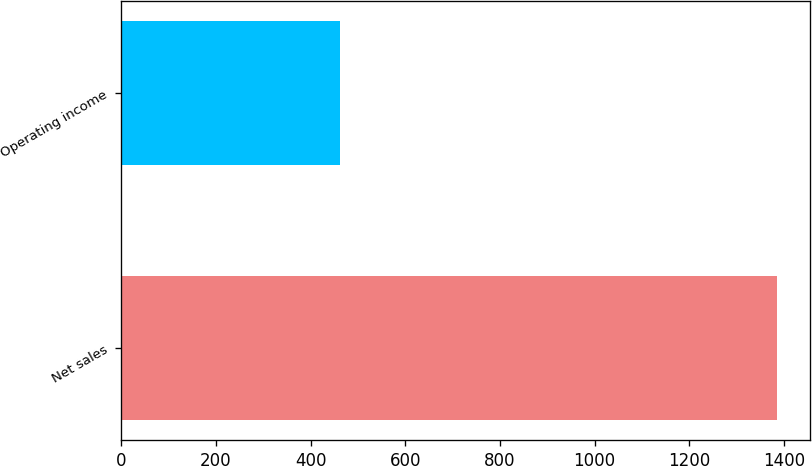Convert chart to OTSL. <chart><loc_0><loc_0><loc_500><loc_500><bar_chart><fcel>Net sales<fcel>Operating income<nl><fcel>1386<fcel>461<nl></chart> 